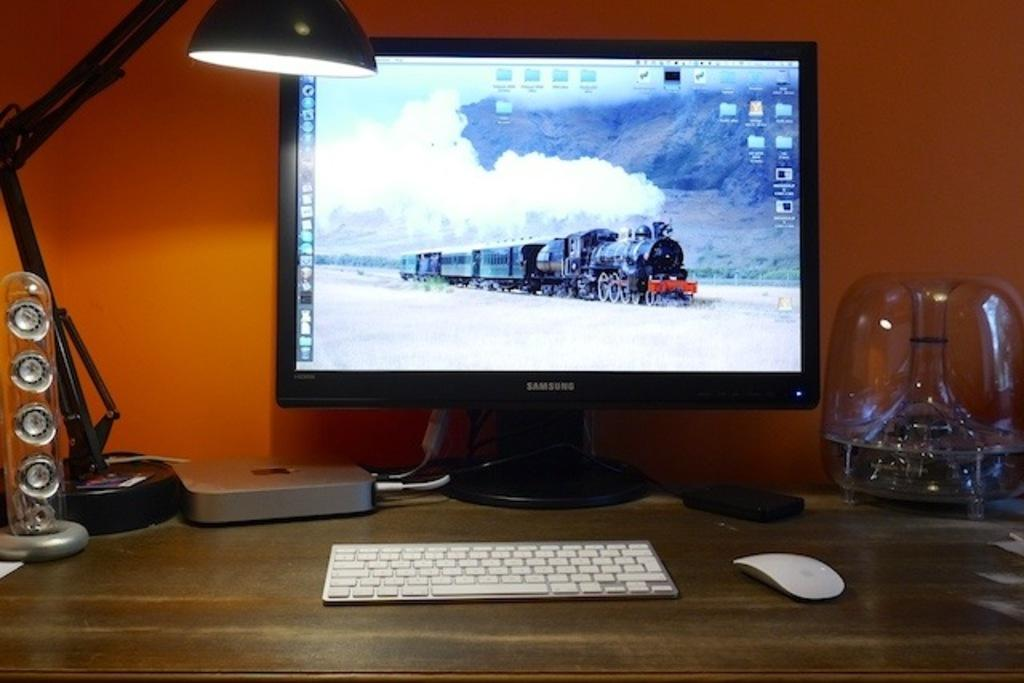<image>
Create a compact narrative representing the image presented. The desktop on the Samsung computer monitor shows a steam locomotive. 